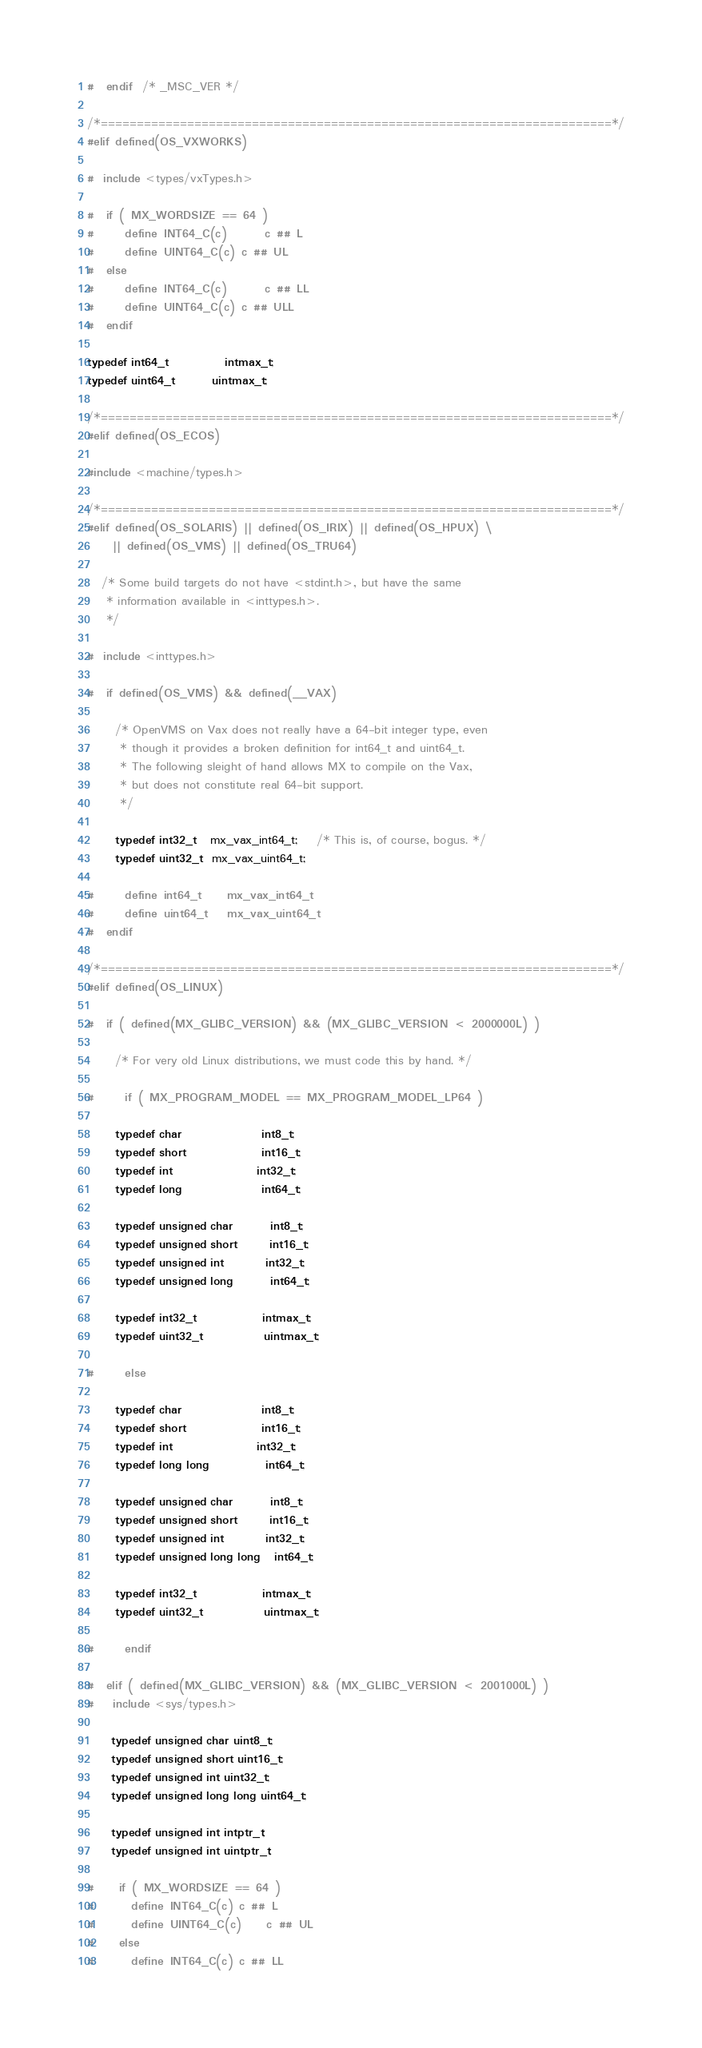<code> <loc_0><loc_0><loc_500><loc_500><_C_>
#  endif   /* _MSC_VER */

/*=======================================================================*/
#elif defined(OS_VXWORKS)

#  include <types/vxTypes.h>

#  if ( MX_WORDSIZE == 64 )
#     define INT64_C(c)		c ## L
#     define UINT64_C(c)	c ## UL
#  else
#     define INT64_C(c)		c ## LL
#     define UINT64_C(c)	c ## ULL
#  endif

typedef int64_t			intmax_t;
typedef uint64_t		uintmax_t;

/*=======================================================================*/
#elif defined(OS_ECOS)

#include <machine/types.h>

/*=======================================================================*/
#elif defined(OS_SOLARIS) || defined(OS_IRIX) || defined(OS_HPUX) \
	|| defined(OS_VMS) || defined(OS_TRU64)

   /* Some build targets do not have <stdint.h>, but have the same
    * information available in <inttypes.h>.
    */

#  include <inttypes.h>

#  if defined(OS_VMS) && defined(__VAX)

      /* OpenVMS on Vax does not really have a 64-bit integer type, even
       * though it provides a broken definition for int64_t and uint64_t.
       * The following sleight of hand allows MX to compile on the Vax,
       * but does not constitute real 64-bit support.
       */

      typedef int32_t   mx_vax_int64_t;    /* This is, of course, bogus. */
      typedef uint32_t  mx_vax_uint64_t;

#     define int64_t    mx_vax_int64_t
#     define uint64_t   mx_vax_uint64_t
#  endif

/*=======================================================================*/
#elif defined(OS_LINUX)

#  if ( defined(MX_GLIBC_VERSION) && (MX_GLIBC_VERSION < 2000000L) )

      /* For very old Linux distributions, we must code this by hand. */

#     if ( MX_PROGRAM_MODEL == MX_PROGRAM_MODEL_LP64 )

      typedef char                 int8_t;
      typedef short                int16_t;
      typedef int                  int32_t;
      typedef long                 int64_t;

      typedef unsigned char        int8_t;
      typedef unsigned short       int16_t;
      typedef unsigned int         int32_t;
      typedef unsigned long        int64_t;

      typedef int32_t              intmax_t;
      typedef uint32_t             uintmax_t;

#     else

      typedef char                 int8_t;
      typedef short                int16_t;
      typedef int                  int32_t;
      typedef long long            int64_t;

      typedef unsigned char        int8_t;
      typedef unsigned short       int16_t;
      typedef unsigned int         int32_t;
      typedef unsigned long long   int64_t;

      typedef int32_t              intmax_t;
      typedef uint32_t             uintmax_t;

#     endif

#  elif ( defined(MX_GLIBC_VERSION) && (MX_GLIBC_VERSION < 2001000L) )
#    include <sys/types.h>

     typedef unsigned char uint8_t;
     typedef unsigned short uint16_t;
     typedef unsigned int uint32_t;
     typedef unsigned long long uint64_t;

     typedef unsigned int intptr_t;
     typedef unsigned int uintptr_t;

#    if ( MX_WORDSIZE == 64 )
#      define INT64_C(c)	c ## L
#      define UINT64_C(c)	c ## UL
#    else
#      define INT64_C(c)	c ## LL</code> 